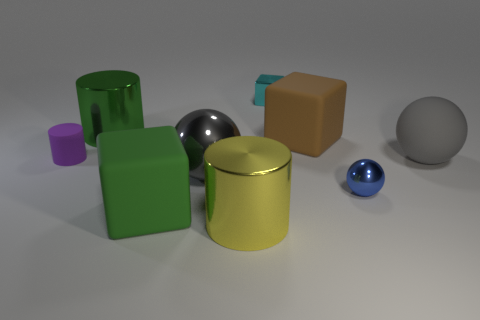Subtract all blue shiny spheres. How many spheres are left? 2 Subtract all blue blocks. How many gray balls are left? 2 Subtract 1 blocks. How many blocks are left? 2 Add 1 tiny cylinders. How many objects exist? 10 Subtract all green cylinders. How many cylinders are left? 2 Add 4 large brown things. How many large brown things are left? 5 Add 5 small balls. How many small balls exist? 6 Subtract 0 blue cubes. How many objects are left? 9 Subtract all spheres. How many objects are left? 6 Subtract all gray blocks. Subtract all green balls. How many blocks are left? 3 